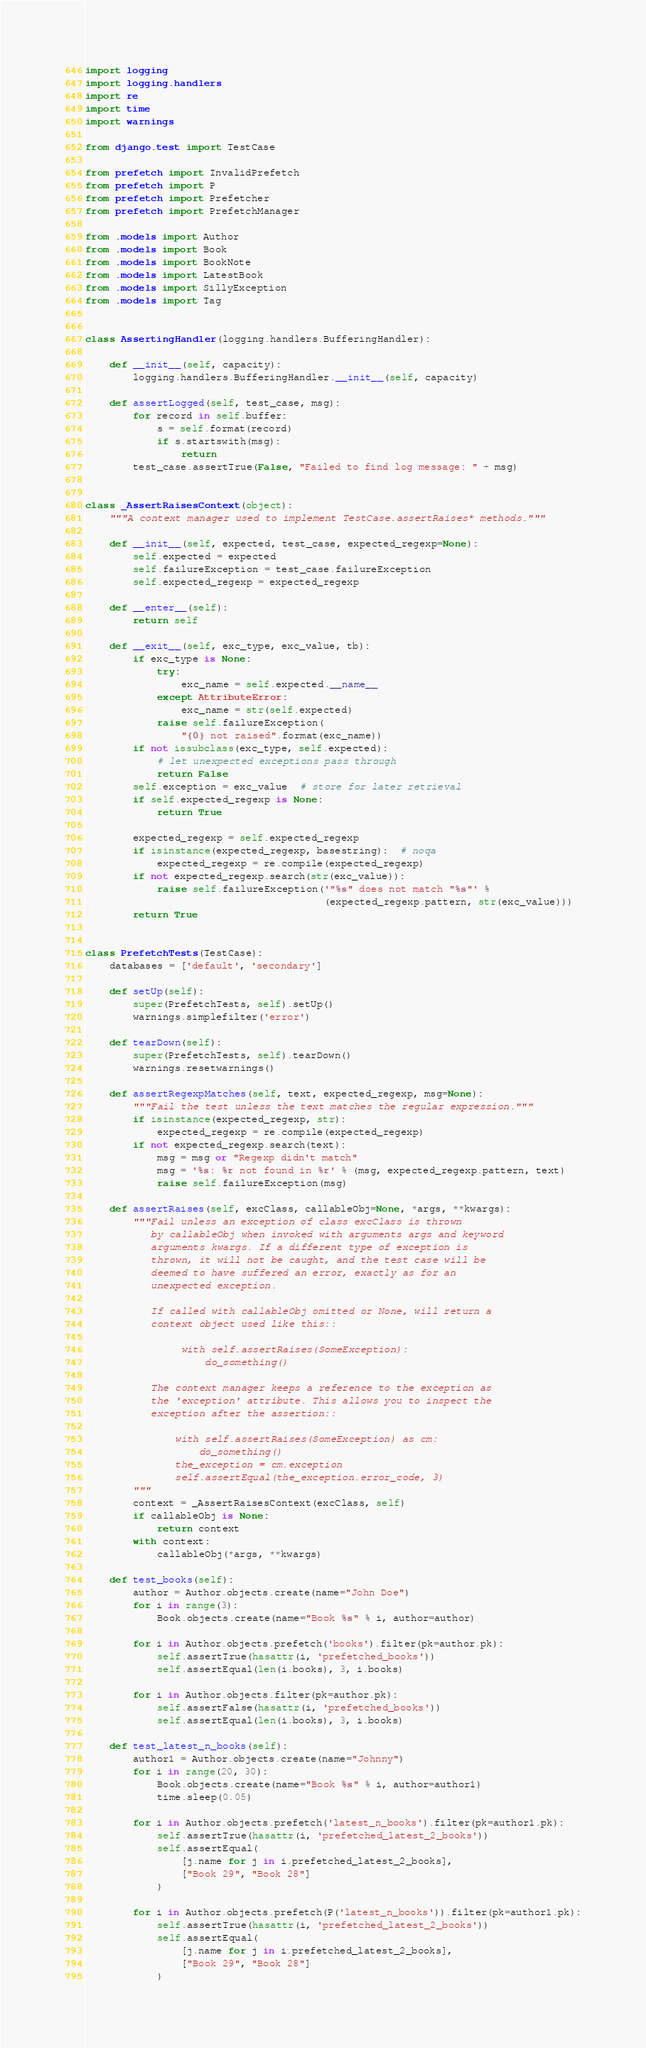Convert code to text. <code><loc_0><loc_0><loc_500><loc_500><_Python_>import logging
import logging.handlers
import re
import time
import warnings

from django.test import TestCase

from prefetch import InvalidPrefetch
from prefetch import P
from prefetch import Prefetcher
from prefetch import PrefetchManager

from .models import Author
from .models import Book
from .models import BookNote
from .models import LatestBook
from .models import SillyException
from .models import Tag


class AssertingHandler(logging.handlers.BufferingHandler):

    def __init__(self, capacity):
        logging.handlers.BufferingHandler.__init__(self, capacity)

    def assertLogged(self, test_case, msg):
        for record in self.buffer:
            s = self.format(record)
            if s.startswith(msg):
                return
        test_case.assertTrue(False, "Failed to find log message: " + msg)


class _AssertRaisesContext(object):
    """A context manager used to implement TestCase.assertRaises* methods."""

    def __init__(self, expected, test_case, expected_regexp=None):
        self.expected = expected
        self.failureException = test_case.failureException
        self.expected_regexp = expected_regexp

    def __enter__(self):
        return self

    def __exit__(self, exc_type, exc_value, tb):
        if exc_type is None:
            try:
                exc_name = self.expected.__name__
            except AttributeError:
                exc_name = str(self.expected)
            raise self.failureException(
                "{0} not raised".format(exc_name))
        if not issubclass(exc_type, self.expected):
            # let unexpected exceptions pass through
            return False
        self.exception = exc_value  # store for later retrieval
        if self.expected_regexp is None:
            return True

        expected_regexp = self.expected_regexp
        if isinstance(expected_regexp, basestring):  # noqa
            expected_regexp = re.compile(expected_regexp)
        if not expected_regexp.search(str(exc_value)):
            raise self.failureException('"%s" does not match "%s"' %
                                        (expected_regexp.pattern, str(exc_value)))
        return True


class PrefetchTests(TestCase):
    databases = ['default', 'secondary']

    def setUp(self):
        super(PrefetchTests, self).setUp()
        warnings.simplefilter('error')

    def tearDown(self):
        super(PrefetchTests, self).tearDown()
        warnings.resetwarnings()

    def assertRegexpMatches(self, text, expected_regexp, msg=None):
        """Fail the test unless the text matches the regular expression."""
        if isinstance(expected_regexp, str):
            expected_regexp = re.compile(expected_regexp)
        if not expected_regexp.search(text):
            msg = msg or "Regexp didn't match"
            msg = '%s: %r not found in %r' % (msg, expected_regexp.pattern, text)
            raise self.failureException(msg)

    def assertRaises(self, excClass, callableObj=None, *args, **kwargs):
        """Fail unless an exception of class excClass is thrown
           by callableObj when invoked with arguments args and keyword
           arguments kwargs. If a different type of exception is
           thrown, it will not be caught, and the test case will be
           deemed to have suffered an error, exactly as for an
           unexpected exception.

           If called with callableObj omitted or None, will return a
           context object used like this::

                with self.assertRaises(SomeException):
                    do_something()

           The context manager keeps a reference to the exception as
           the 'exception' attribute. This allows you to inspect the
           exception after the assertion::

               with self.assertRaises(SomeException) as cm:
                   do_something()
               the_exception = cm.exception
               self.assertEqual(the_exception.error_code, 3)
        """
        context = _AssertRaisesContext(excClass, self)
        if callableObj is None:
            return context
        with context:
            callableObj(*args, **kwargs)

    def test_books(self):
        author = Author.objects.create(name="John Doe")
        for i in range(3):
            Book.objects.create(name="Book %s" % i, author=author)

        for i in Author.objects.prefetch('books').filter(pk=author.pk):
            self.assertTrue(hasattr(i, 'prefetched_books'))
            self.assertEqual(len(i.books), 3, i.books)

        for i in Author.objects.filter(pk=author.pk):
            self.assertFalse(hasattr(i, 'prefetched_books'))
            self.assertEqual(len(i.books), 3, i.books)

    def test_latest_n_books(self):
        author1 = Author.objects.create(name="Johnny")
        for i in range(20, 30):
            Book.objects.create(name="Book %s" % i, author=author1)
            time.sleep(0.05)

        for i in Author.objects.prefetch('latest_n_books').filter(pk=author1.pk):
            self.assertTrue(hasattr(i, 'prefetched_latest_2_books'))
            self.assertEqual(
                [j.name for j in i.prefetched_latest_2_books],
                ["Book 29", "Book 28"]
            )

        for i in Author.objects.prefetch(P('latest_n_books')).filter(pk=author1.pk):
            self.assertTrue(hasattr(i, 'prefetched_latest_2_books'))
            self.assertEqual(
                [j.name for j in i.prefetched_latest_2_books],
                ["Book 29", "Book 28"]
            )
</code> 